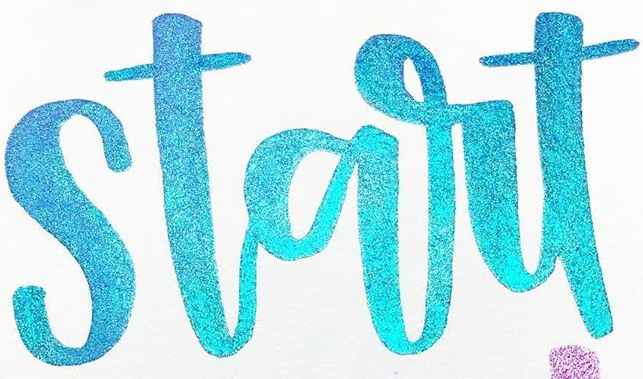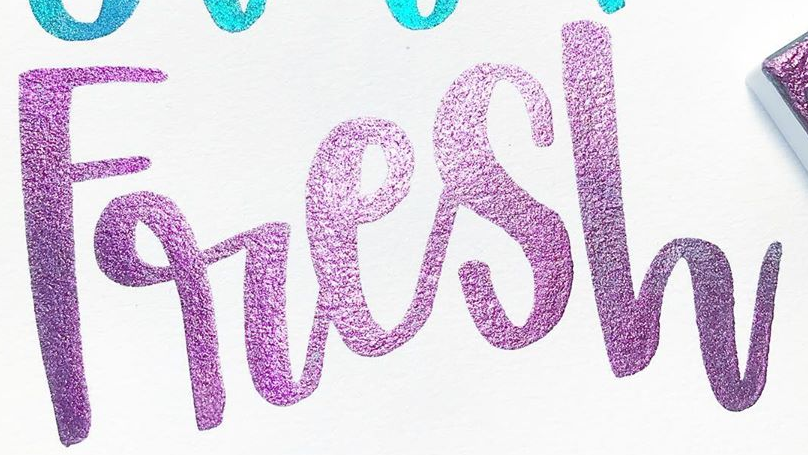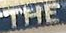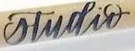Transcribe the words shown in these images in order, separated by a semicolon. start; Fresh; THE; studir 